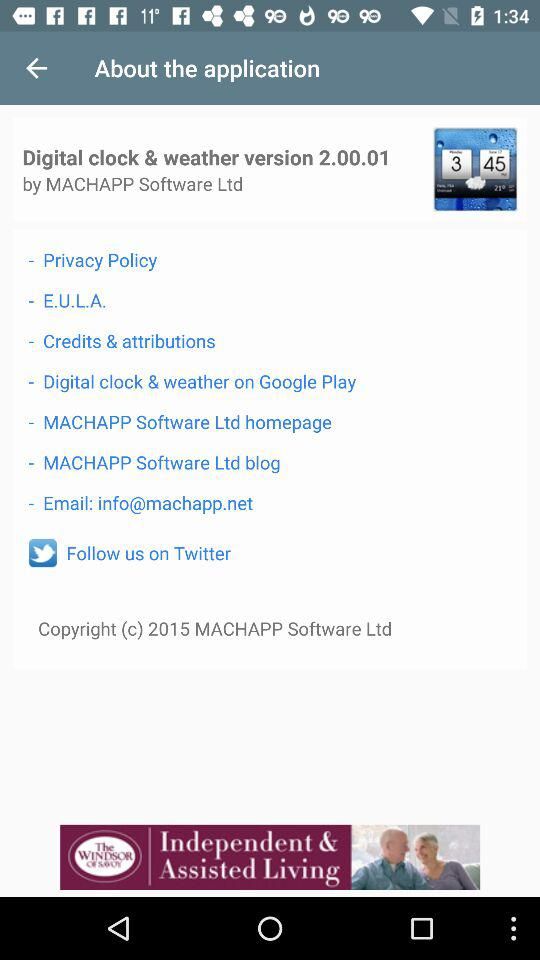What is the year of copyright of the application? The year of copyright is 2015. 